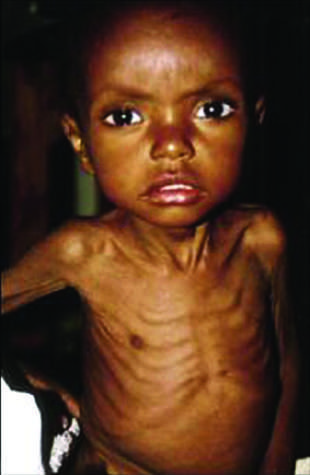what appears to be too large for the emaciated body?
Answer the question using a single word or phrase. The head 